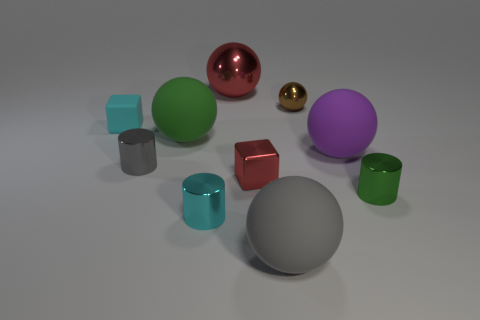Subtract all green matte balls. How many balls are left? 4 Subtract all green spheres. How many spheres are left? 4 Subtract all red cubes. Subtract all yellow spheres. How many cubes are left? 1 Subtract all cylinders. How many objects are left? 7 Add 5 purple things. How many purple things are left? 6 Add 9 small brown shiny spheres. How many small brown shiny spheres exist? 10 Subtract 0 blue cubes. How many objects are left? 10 Subtract all gray shiny objects. Subtract all small green metal objects. How many objects are left? 8 